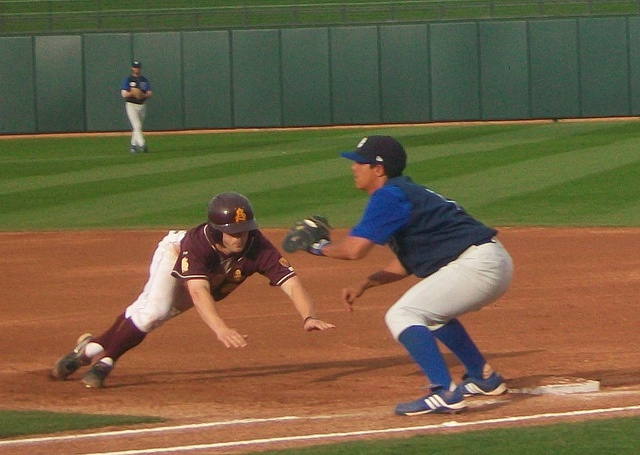Describe the objects in this image and their specific colors. I can see people in darkgreen, navy, black, brown, and gray tones, people in darkgreen, maroon, black, lightgray, and brown tones, people in darkgreen, gray, darkgray, and black tones, baseball glove in darkgreen, gray, and black tones, and baseball glove in darkgreen, maroon, and gray tones in this image. 